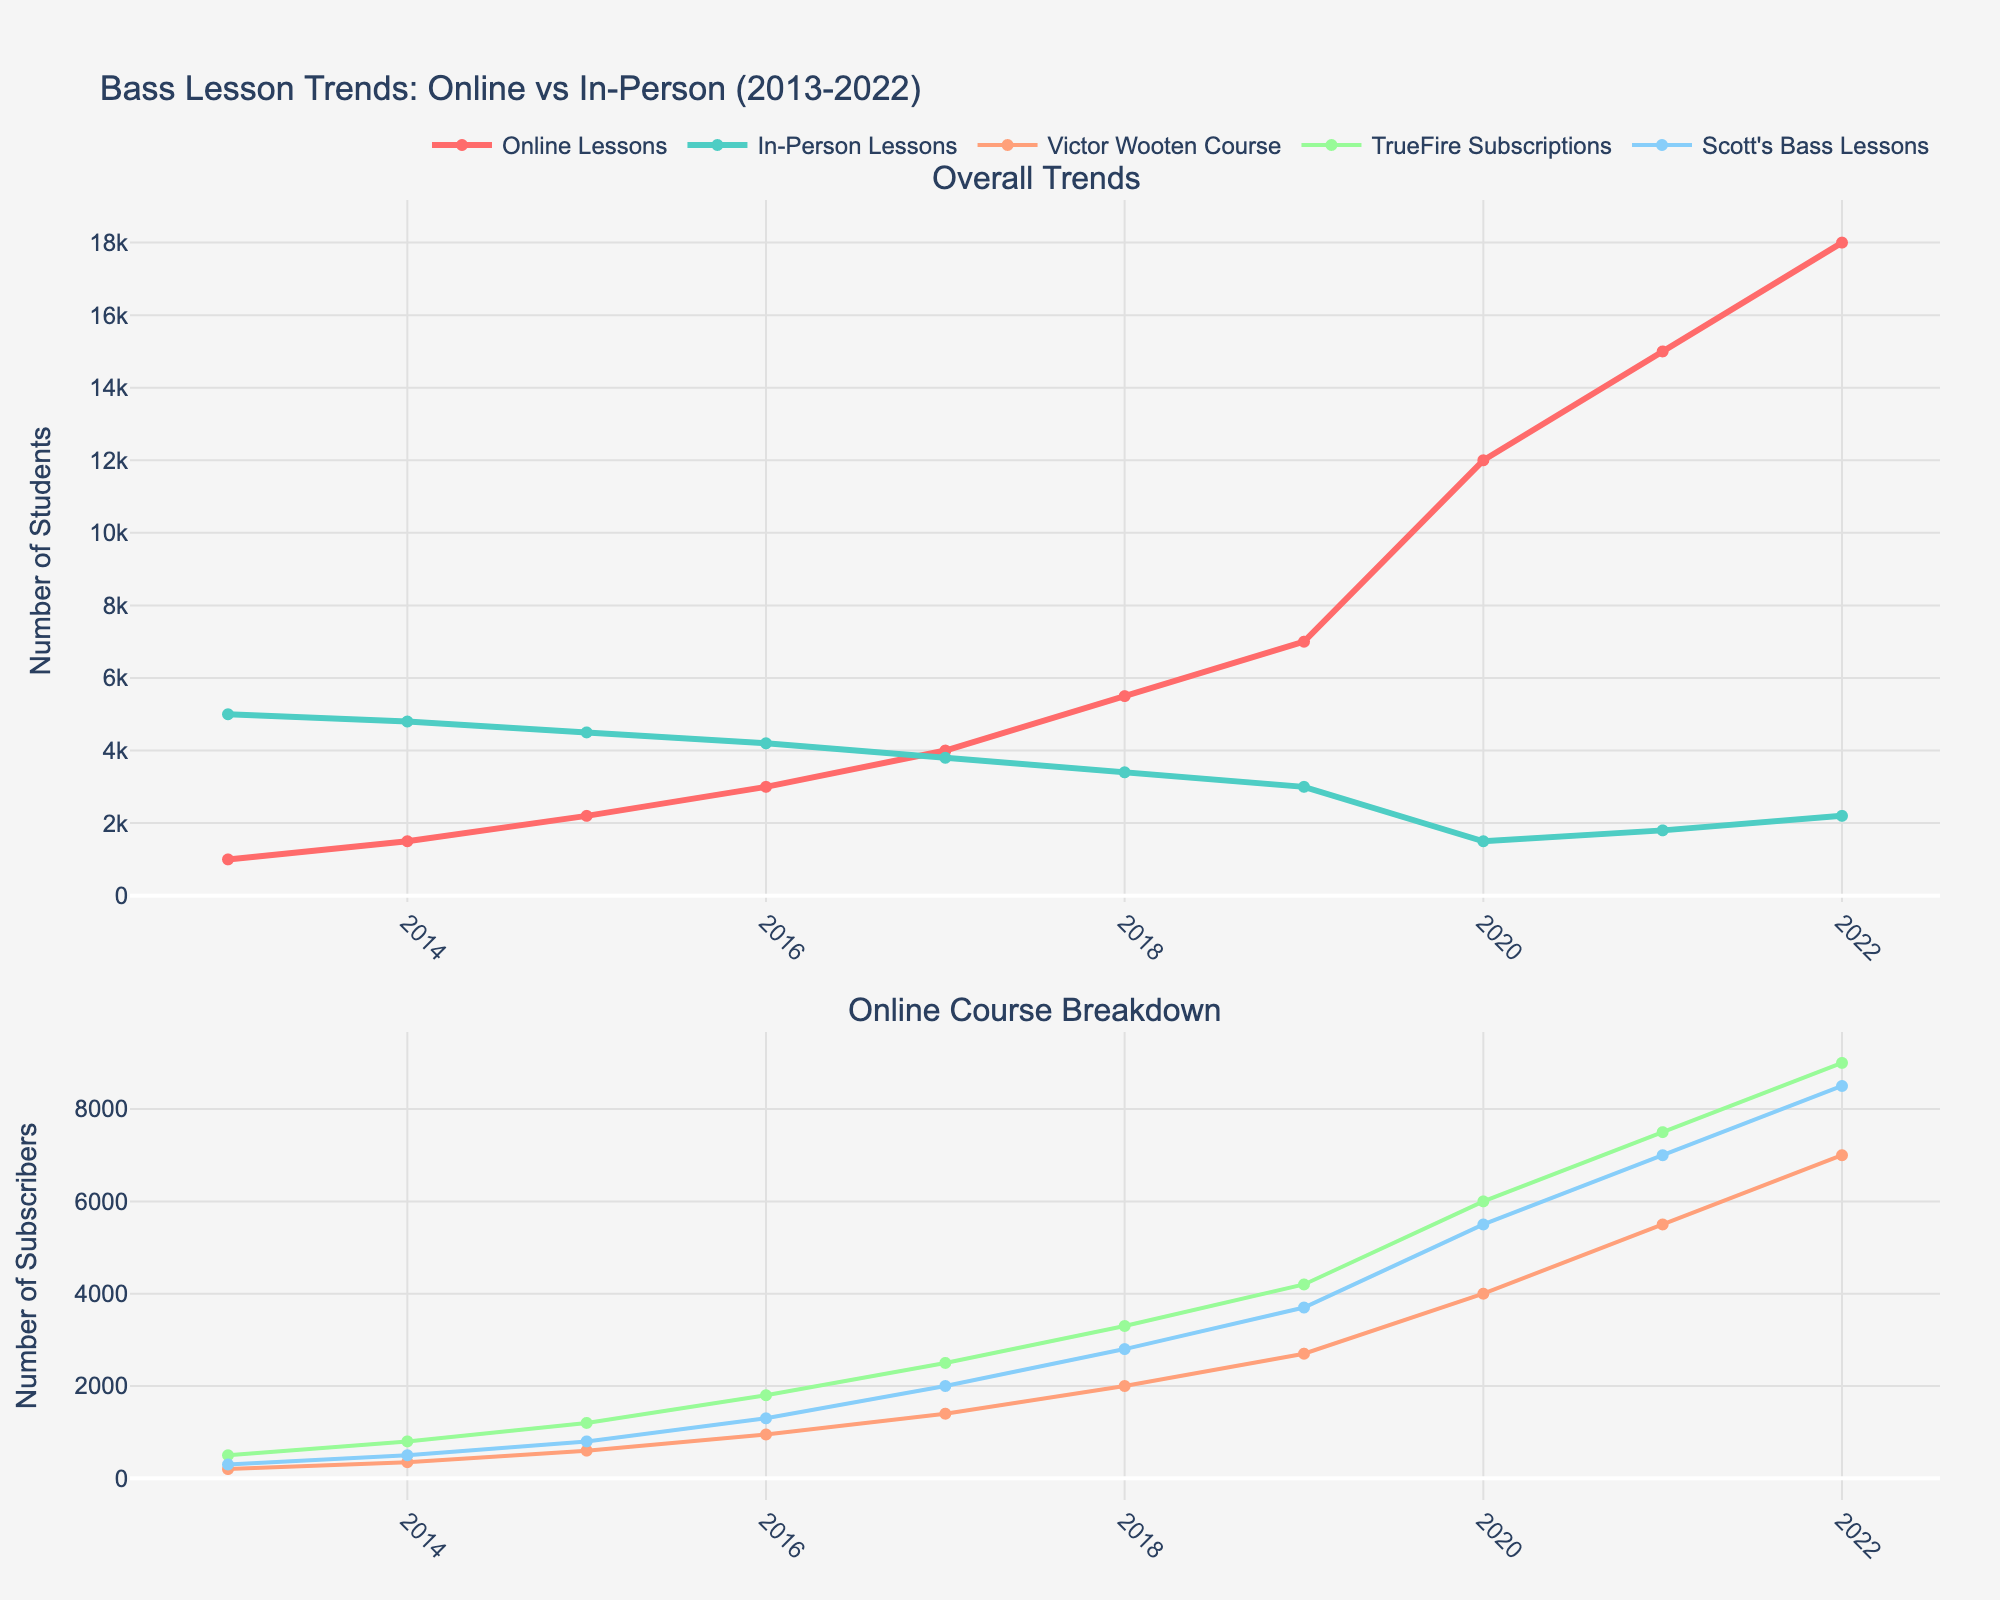What's the title of the plot? The title of the plot is positioned at the top of the figure. It reads 'Bass Lesson Trends: Online vs In-Person (2013-2022)'.
Answer: Bass Lesson Trends: Online vs In-Person (2013-2022) What's the trend for in-person bass lessons from 2013 to 2022? The figure shows a line chart for in-person bass lessons starting at 5000 in 2013 and decreasing steadily to 2200 in 2022.
Answer: Decreasing Which year did online bass lessons surpass in-person bass lessons? By observing the points where the red (online lessons) and teal (in-person lessons) lines intersect, the crossover occurs between 2018 and 2019.
Answer: 2018 to 2019 How many online subscriptions did Scott's Bass Lessons have in 2021? In the second subplot, the blue line (Scott’s Bass Lessons) reaches a value of 7000 subscribers in 2021.
Answer: 7000 Which of the three online courses had the highest number of subscribers in 2022? In the second subplot, the Victor Wooten Course (orange), TrueFire (green), and Scott's Bass Lessons (blue) lines in 2022 are at 7000, 9000, and 8500 respectively. The TrueFire Subscriptions have the highest number.
Answer: TrueFire Subscriptions What is the average number of online bass lessons subscriptions from 2013 to 2022? Summing up the values of online bass lessons from 2013 to 2022 (1000+1500+2200+3000+4000+5500+7000+12000+15000+18000) equals 71200, and then dividing by 10 years gives an average of 7120.
Answer: 7120 By how much did Victor Wooten Online Course subscriptions increase from 2014 to 2015? The subscriptions for Victor Wooten's course in 2014 were 350, and in 2015 they were 600. The increase is 600 - 350 = 250.
Answer: 250 Compare the growth rate of TrueFire Bass Subscriptions vs. Scott's Bass Lessons Memberships between 2019 and 2020. TrueFire increased from 4200 to 6000, which is a growth rate of (6000 - 4200) / 4200 = 0.4286 or 42.86%. Scott's increased from 3700 to 5500, resulting in a growth rate of (5500 - 3700) / 3700 = 0.4865 or 48.65%. Scott's Bass Lessons had a higher growth rate.
Answer: Scott's Bass Lessons What was the overall trend for all online courses during the COVID-19 pandemic starting from 2020 to 2021? Both subplots show a significant increase for all online courses and lessons during these years, indicating a positive trend due to the pandemic's impact.
Answer: Increasing 